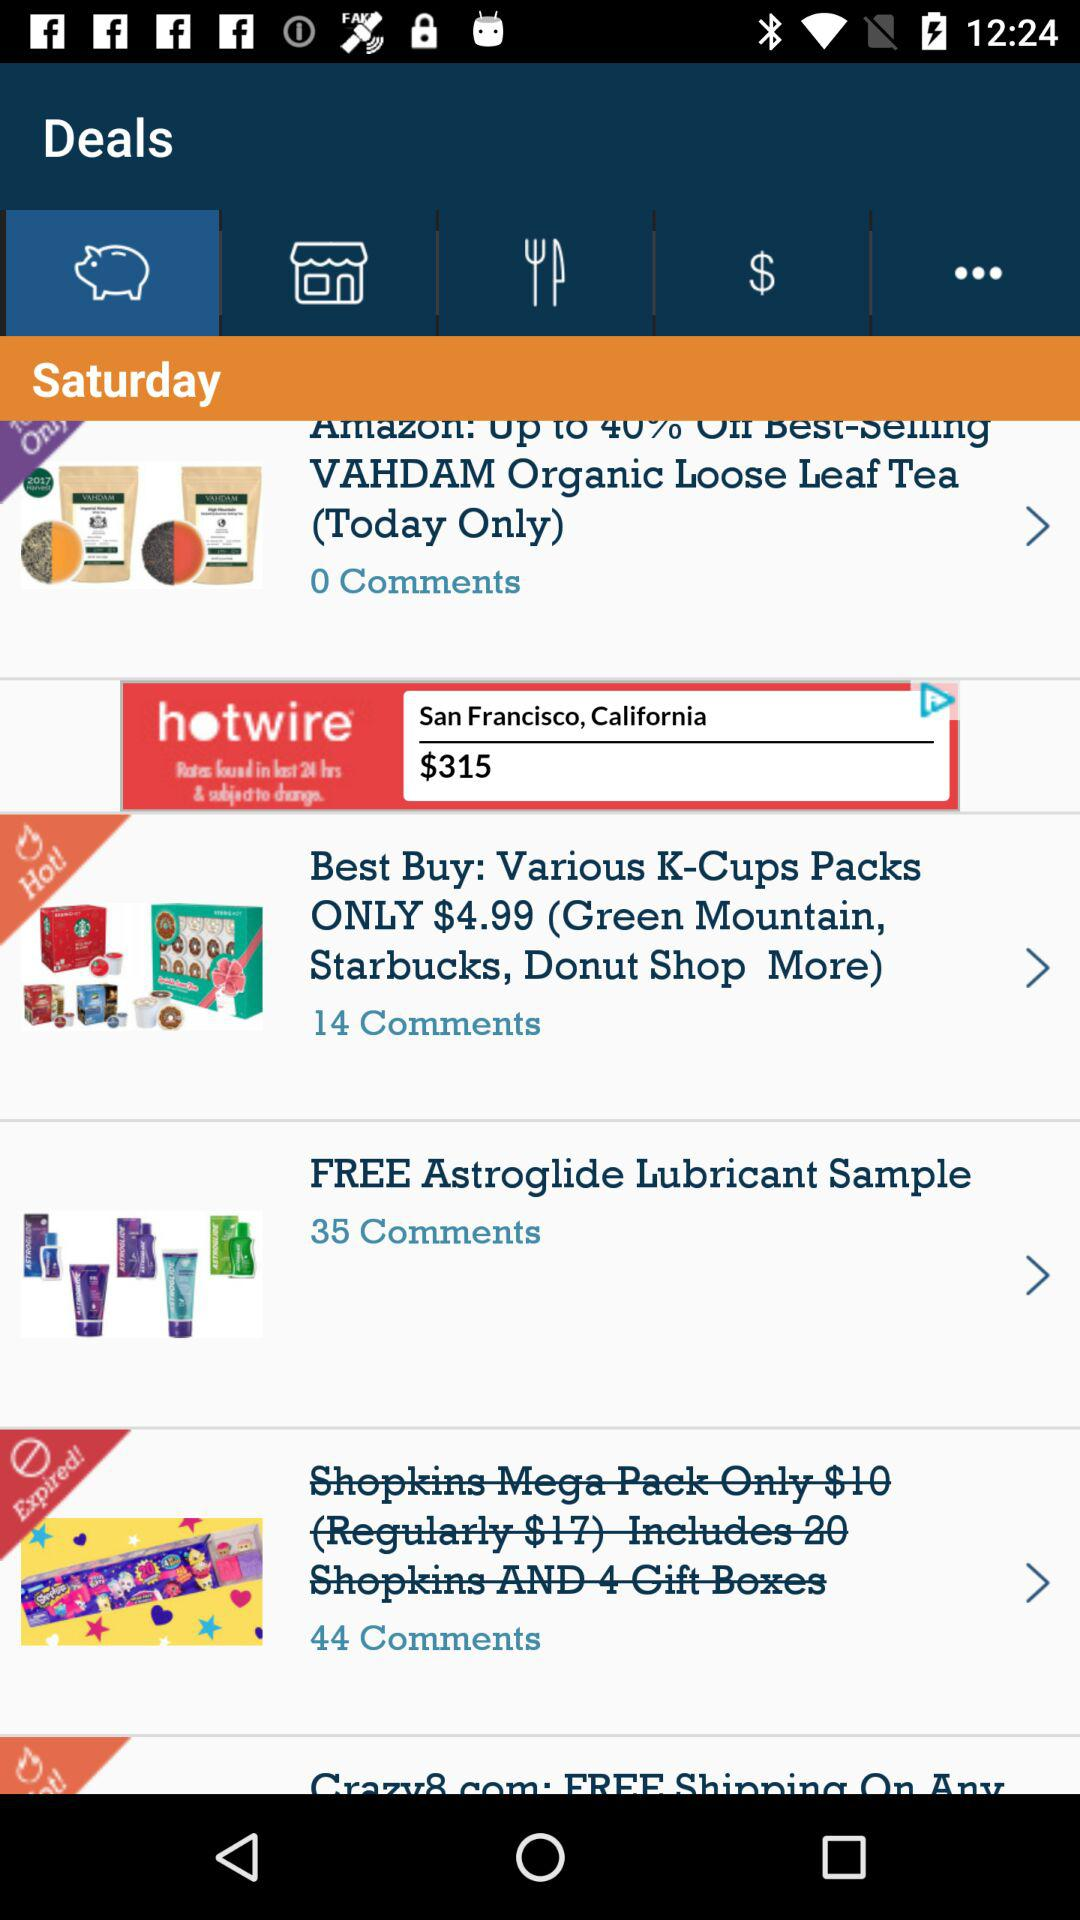How many comments has "Shopkins Mega Pack" received? There are 44 comments for "Shopkins Mega Pack". 